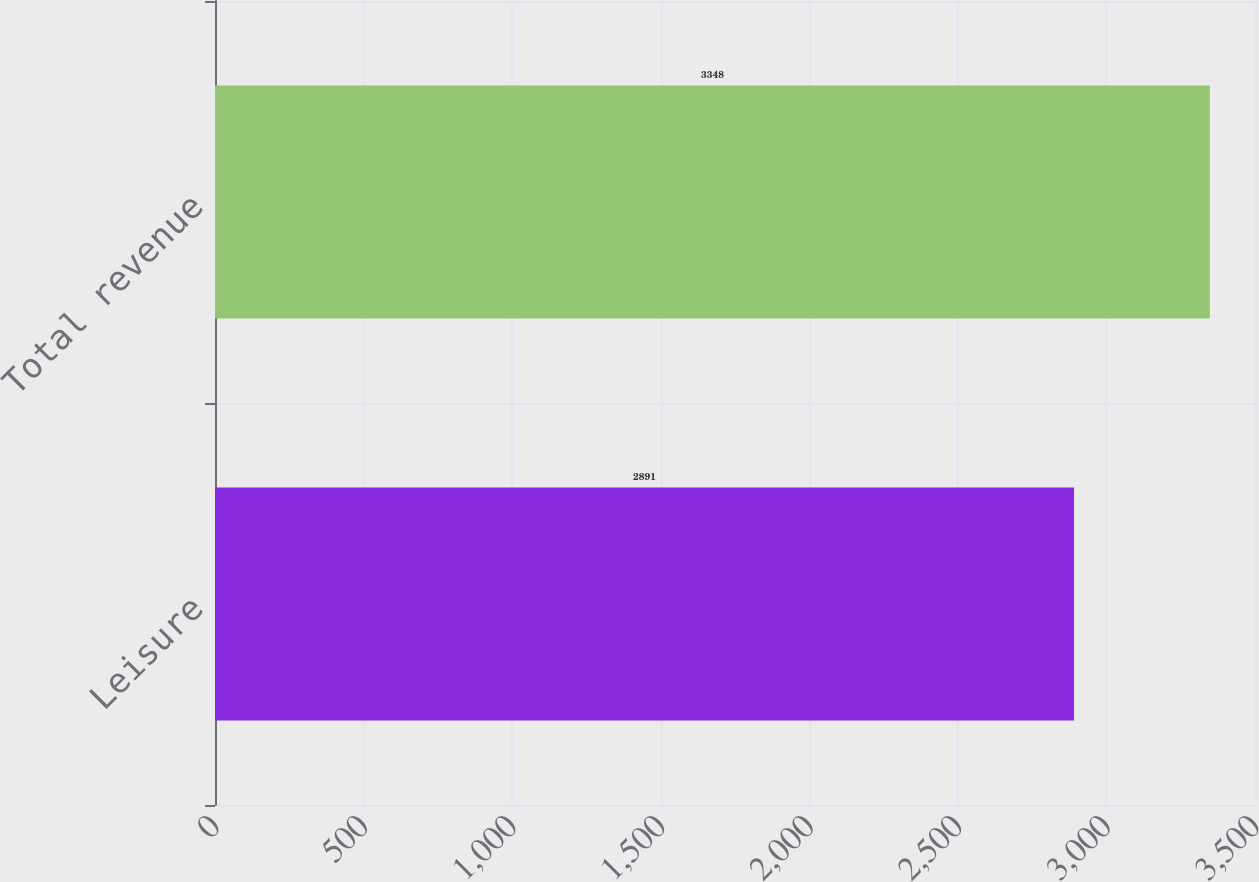Convert chart to OTSL. <chart><loc_0><loc_0><loc_500><loc_500><bar_chart><fcel>Leisure<fcel>Total revenue<nl><fcel>2891<fcel>3348<nl></chart> 